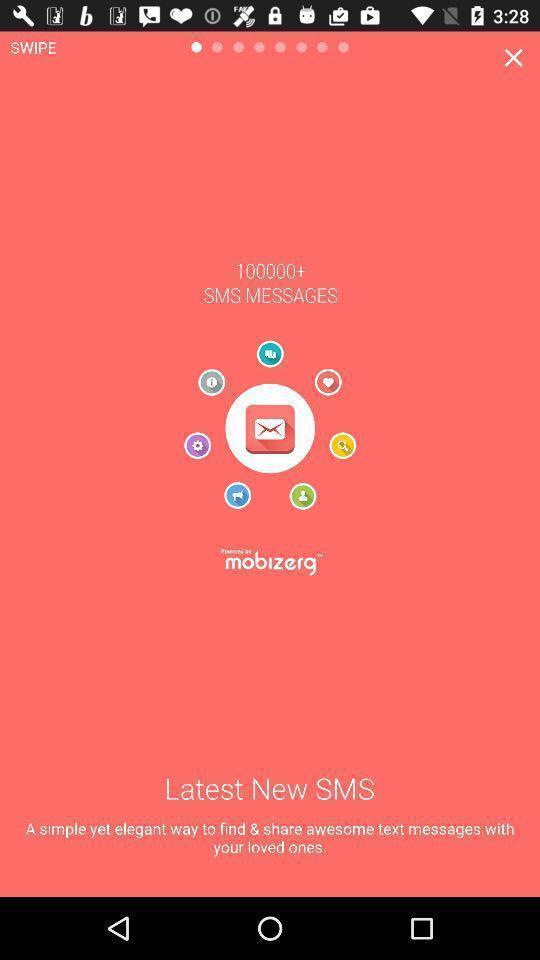What details can you identify in this image? Welcome screen. 